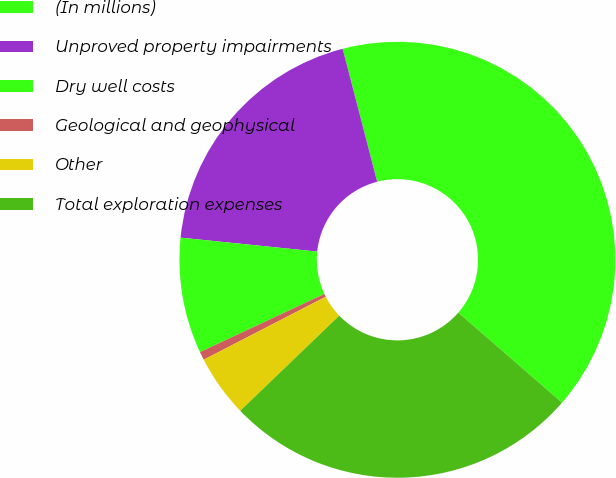Convert chart to OTSL. <chart><loc_0><loc_0><loc_500><loc_500><pie_chart><fcel>(In millions)<fcel>Unproved property impairments<fcel>Dry well costs<fcel>Geological and geophysical<fcel>Other<fcel>Total exploration expenses<nl><fcel>40.42%<fcel>19.34%<fcel>8.58%<fcel>0.62%<fcel>4.6%<fcel>26.44%<nl></chart> 